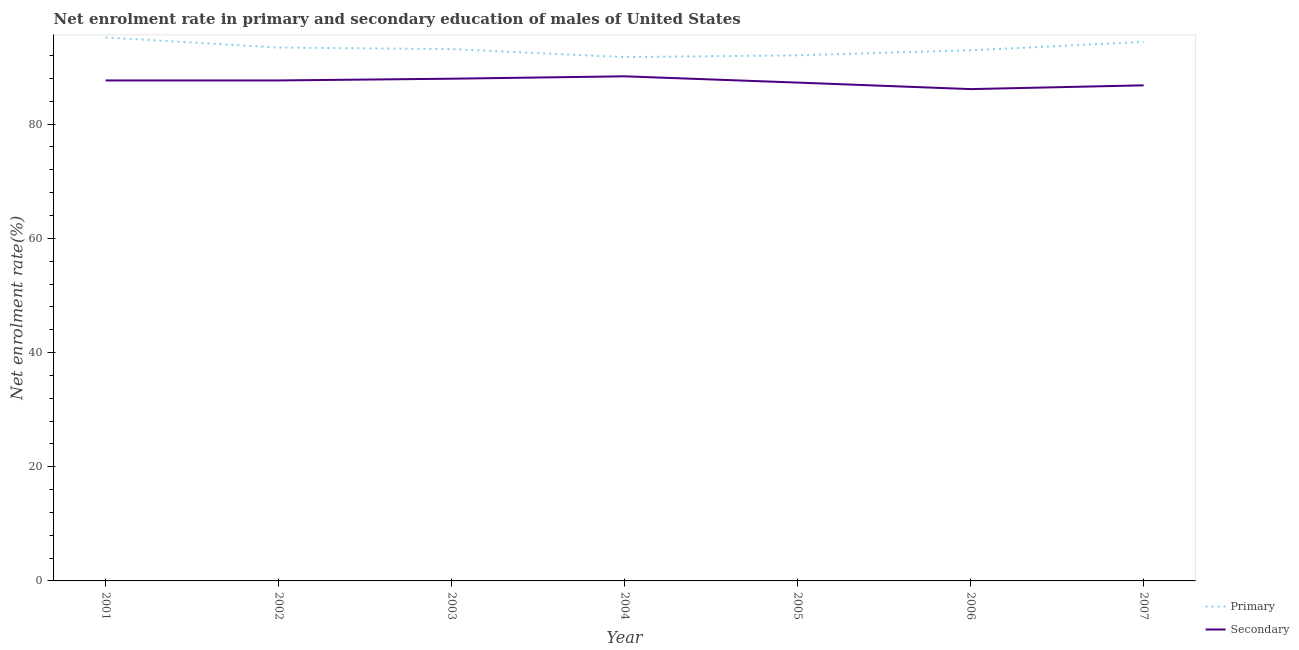Is the number of lines equal to the number of legend labels?
Ensure brevity in your answer.  Yes. What is the enrollment rate in secondary education in 2001?
Give a very brief answer. 87.65. Across all years, what is the maximum enrollment rate in primary education?
Provide a succinct answer. 95.18. Across all years, what is the minimum enrollment rate in secondary education?
Your answer should be compact. 86.13. What is the total enrollment rate in primary education in the graph?
Provide a short and direct response. 652.87. What is the difference between the enrollment rate in primary education in 2004 and that in 2006?
Make the answer very short. -1.2. What is the difference between the enrollment rate in secondary education in 2004 and the enrollment rate in primary education in 2006?
Your response must be concise. -4.56. What is the average enrollment rate in secondary education per year?
Provide a short and direct response. 87.41. In the year 2007, what is the difference between the enrollment rate in primary education and enrollment rate in secondary education?
Your answer should be compact. 7.61. In how many years, is the enrollment rate in primary education greater than 84 %?
Your response must be concise. 7. What is the ratio of the enrollment rate in primary education in 2004 to that in 2006?
Offer a terse response. 0.99. Is the enrollment rate in secondary education in 2001 less than that in 2002?
Your answer should be compact. Yes. What is the difference between the highest and the second highest enrollment rate in primary education?
Ensure brevity in your answer.  0.77. What is the difference between the highest and the lowest enrollment rate in secondary education?
Offer a very short reply. 2.24. Is the sum of the enrollment rate in secondary education in 2004 and 2006 greater than the maximum enrollment rate in primary education across all years?
Ensure brevity in your answer.  Yes. Is the enrollment rate in secondary education strictly greater than the enrollment rate in primary education over the years?
Ensure brevity in your answer.  No. What is the difference between two consecutive major ticks on the Y-axis?
Offer a very short reply. 20. Does the graph contain any zero values?
Provide a short and direct response. No. Does the graph contain grids?
Your answer should be compact. No. What is the title of the graph?
Give a very brief answer. Net enrolment rate in primary and secondary education of males of United States. What is the label or title of the Y-axis?
Provide a succinct answer. Net enrolment rate(%). What is the Net enrolment rate(%) in Primary in 2001?
Provide a short and direct response. 95.18. What is the Net enrolment rate(%) in Secondary in 2001?
Offer a very short reply. 87.65. What is the Net enrolment rate(%) in Primary in 2002?
Offer a terse response. 93.41. What is the Net enrolment rate(%) of Secondary in 2002?
Your answer should be very brief. 87.65. What is the Net enrolment rate(%) in Primary in 2003?
Provide a short and direct response. 93.14. What is the Net enrolment rate(%) of Secondary in 2003?
Ensure brevity in your answer.  87.96. What is the Net enrolment rate(%) in Primary in 2004?
Keep it short and to the point. 91.74. What is the Net enrolment rate(%) in Secondary in 2004?
Provide a succinct answer. 88.38. What is the Net enrolment rate(%) of Primary in 2005?
Your answer should be compact. 92.05. What is the Net enrolment rate(%) of Secondary in 2005?
Give a very brief answer. 87.27. What is the Net enrolment rate(%) of Primary in 2006?
Your response must be concise. 92.94. What is the Net enrolment rate(%) in Secondary in 2006?
Give a very brief answer. 86.13. What is the Net enrolment rate(%) of Primary in 2007?
Provide a succinct answer. 94.41. What is the Net enrolment rate(%) in Secondary in 2007?
Offer a very short reply. 86.8. Across all years, what is the maximum Net enrolment rate(%) in Primary?
Provide a short and direct response. 95.18. Across all years, what is the maximum Net enrolment rate(%) of Secondary?
Your response must be concise. 88.38. Across all years, what is the minimum Net enrolment rate(%) in Primary?
Your answer should be compact. 91.74. Across all years, what is the minimum Net enrolment rate(%) of Secondary?
Make the answer very short. 86.13. What is the total Net enrolment rate(%) of Primary in the graph?
Give a very brief answer. 652.87. What is the total Net enrolment rate(%) in Secondary in the graph?
Your answer should be compact. 611.84. What is the difference between the Net enrolment rate(%) of Primary in 2001 and that in 2002?
Provide a succinct answer. 1.77. What is the difference between the Net enrolment rate(%) of Secondary in 2001 and that in 2002?
Your response must be concise. -0. What is the difference between the Net enrolment rate(%) in Primary in 2001 and that in 2003?
Your answer should be very brief. 2.04. What is the difference between the Net enrolment rate(%) in Secondary in 2001 and that in 2003?
Your response must be concise. -0.3. What is the difference between the Net enrolment rate(%) in Primary in 2001 and that in 2004?
Ensure brevity in your answer.  3.44. What is the difference between the Net enrolment rate(%) in Secondary in 2001 and that in 2004?
Your answer should be compact. -0.72. What is the difference between the Net enrolment rate(%) of Primary in 2001 and that in 2005?
Keep it short and to the point. 3.13. What is the difference between the Net enrolment rate(%) in Secondary in 2001 and that in 2005?
Your answer should be compact. 0.38. What is the difference between the Net enrolment rate(%) in Primary in 2001 and that in 2006?
Provide a succinct answer. 2.24. What is the difference between the Net enrolment rate(%) of Secondary in 2001 and that in 2006?
Give a very brief answer. 1.52. What is the difference between the Net enrolment rate(%) in Primary in 2001 and that in 2007?
Provide a short and direct response. 0.77. What is the difference between the Net enrolment rate(%) in Secondary in 2001 and that in 2007?
Offer a terse response. 0.86. What is the difference between the Net enrolment rate(%) in Primary in 2002 and that in 2003?
Your answer should be compact. 0.28. What is the difference between the Net enrolment rate(%) in Secondary in 2002 and that in 2003?
Offer a very short reply. -0.3. What is the difference between the Net enrolment rate(%) in Primary in 2002 and that in 2004?
Your answer should be very brief. 1.67. What is the difference between the Net enrolment rate(%) of Secondary in 2002 and that in 2004?
Your response must be concise. -0.72. What is the difference between the Net enrolment rate(%) of Primary in 2002 and that in 2005?
Provide a short and direct response. 1.36. What is the difference between the Net enrolment rate(%) of Secondary in 2002 and that in 2005?
Give a very brief answer. 0.38. What is the difference between the Net enrolment rate(%) of Primary in 2002 and that in 2006?
Your answer should be very brief. 0.47. What is the difference between the Net enrolment rate(%) of Secondary in 2002 and that in 2006?
Offer a very short reply. 1.52. What is the difference between the Net enrolment rate(%) in Primary in 2002 and that in 2007?
Give a very brief answer. -0.99. What is the difference between the Net enrolment rate(%) in Secondary in 2002 and that in 2007?
Offer a very short reply. 0.86. What is the difference between the Net enrolment rate(%) of Primary in 2003 and that in 2004?
Offer a very short reply. 1.4. What is the difference between the Net enrolment rate(%) in Secondary in 2003 and that in 2004?
Ensure brevity in your answer.  -0.42. What is the difference between the Net enrolment rate(%) of Primary in 2003 and that in 2005?
Your response must be concise. 1.09. What is the difference between the Net enrolment rate(%) of Secondary in 2003 and that in 2005?
Offer a very short reply. 0.68. What is the difference between the Net enrolment rate(%) in Primary in 2003 and that in 2006?
Provide a short and direct response. 0.2. What is the difference between the Net enrolment rate(%) of Secondary in 2003 and that in 2006?
Offer a terse response. 1.82. What is the difference between the Net enrolment rate(%) of Primary in 2003 and that in 2007?
Your response must be concise. -1.27. What is the difference between the Net enrolment rate(%) of Secondary in 2003 and that in 2007?
Your answer should be very brief. 1.16. What is the difference between the Net enrolment rate(%) of Primary in 2004 and that in 2005?
Make the answer very short. -0.31. What is the difference between the Net enrolment rate(%) in Secondary in 2004 and that in 2005?
Provide a succinct answer. 1.1. What is the difference between the Net enrolment rate(%) of Primary in 2004 and that in 2006?
Provide a short and direct response. -1.2. What is the difference between the Net enrolment rate(%) of Secondary in 2004 and that in 2006?
Provide a short and direct response. 2.24. What is the difference between the Net enrolment rate(%) of Primary in 2004 and that in 2007?
Provide a succinct answer. -2.67. What is the difference between the Net enrolment rate(%) of Secondary in 2004 and that in 2007?
Offer a terse response. 1.58. What is the difference between the Net enrolment rate(%) of Primary in 2005 and that in 2006?
Give a very brief answer. -0.89. What is the difference between the Net enrolment rate(%) of Secondary in 2005 and that in 2006?
Make the answer very short. 1.14. What is the difference between the Net enrolment rate(%) in Primary in 2005 and that in 2007?
Ensure brevity in your answer.  -2.36. What is the difference between the Net enrolment rate(%) of Secondary in 2005 and that in 2007?
Your answer should be compact. 0.48. What is the difference between the Net enrolment rate(%) in Primary in 2006 and that in 2007?
Make the answer very short. -1.47. What is the difference between the Net enrolment rate(%) of Secondary in 2006 and that in 2007?
Keep it short and to the point. -0.66. What is the difference between the Net enrolment rate(%) of Primary in 2001 and the Net enrolment rate(%) of Secondary in 2002?
Give a very brief answer. 7.53. What is the difference between the Net enrolment rate(%) of Primary in 2001 and the Net enrolment rate(%) of Secondary in 2003?
Offer a very short reply. 7.22. What is the difference between the Net enrolment rate(%) of Primary in 2001 and the Net enrolment rate(%) of Secondary in 2004?
Offer a terse response. 6.8. What is the difference between the Net enrolment rate(%) in Primary in 2001 and the Net enrolment rate(%) in Secondary in 2005?
Your answer should be very brief. 7.91. What is the difference between the Net enrolment rate(%) in Primary in 2001 and the Net enrolment rate(%) in Secondary in 2006?
Ensure brevity in your answer.  9.05. What is the difference between the Net enrolment rate(%) in Primary in 2001 and the Net enrolment rate(%) in Secondary in 2007?
Your answer should be very brief. 8.38. What is the difference between the Net enrolment rate(%) of Primary in 2002 and the Net enrolment rate(%) of Secondary in 2003?
Ensure brevity in your answer.  5.46. What is the difference between the Net enrolment rate(%) in Primary in 2002 and the Net enrolment rate(%) in Secondary in 2004?
Offer a terse response. 5.04. What is the difference between the Net enrolment rate(%) in Primary in 2002 and the Net enrolment rate(%) in Secondary in 2005?
Keep it short and to the point. 6.14. What is the difference between the Net enrolment rate(%) in Primary in 2002 and the Net enrolment rate(%) in Secondary in 2006?
Your response must be concise. 7.28. What is the difference between the Net enrolment rate(%) in Primary in 2002 and the Net enrolment rate(%) in Secondary in 2007?
Provide a succinct answer. 6.62. What is the difference between the Net enrolment rate(%) of Primary in 2003 and the Net enrolment rate(%) of Secondary in 2004?
Keep it short and to the point. 4.76. What is the difference between the Net enrolment rate(%) of Primary in 2003 and the Net enrolment rate(%) of Secondary in 2005?
Keep it short and to the point. 5.86. What is the difference between the Net enrolment rate(%) of Primary in 2003 and the Net enrolment rate(%) of Secondary in 2006?
Ensure brevity in your answer.  7. What is the difference between the Net enrolment rate(%) of Primary in 2003 and the Net enrolment rate(%) of Secondary in 2007?
Provide a short and direct response. 6.34. What is the difference between the Net enrolment rate(%) in Primary in 2004 and the Net enrolment rate(%) in Secondary in 2005?
Provide a short and direct response. 4.47. What is the difference between the Net enrolment rate(%) in Primary in 2004 and the Net enrolment rate(%) in Secondary in 2006?
Keep it short and to the point. 5.61. What is the difference between the Net enrolment rate(%) in Primary in 2004 and the Net enrolment rate(%) in Secondary in 2007?
Ensure brevity in your answer.  4.94. What is the difference between the Net enrolment rate(%) in Primary in 2005 and the Net enrolment rate(%) in Secondary in 2006?
Give a very brief answer. 5.91. What is the difference between the Net enrolment rate(%) of Primary in 2005 and the Net enrolment rate(%) of Secondary in 2007?
Your response must be concise. 5.25. What is the difference between the Net enrolment rate(%) in Primary in 2006 and the Net enrolment rate(%) in Secondary in 2007?
Provide a short and direct response. 6.14. What is the average Net enrolment rate(%) of Primary per year?
Keep it short and to the point. 93.27. What is the average Net enrolment rate(%) of Secondary per year?
Provide a succinct answer. 87.41. In the year 2001, what is the difference between the Net enrolment rate(%) of Primary and Net enrolment rate(%) of Secondary?
Your response must be concise. 7.53. In the year 2002, what is the difference between the Net enrolment rate(%) in Primary and Net enrolment rate(%) in Secondary?
Ensure brevity in your answer.  5.76. In the year 2003, what is the difference between the Net enrolment rate(%) of Primary and Net enrolment rate(%) of Secondary?
Provide a succinct answer. 5.18. In the year 2004, what is the difference between the Net enrolment rate(%) of Primary and Net enrolment rate(%) of Secondary?
Your response must be concise. 3.37. In the year 2005, what is the difference between the Net enrolment rate(%) of Primary and Net enrolment rate(%) of Secondary?
Make the answer very short. 4.77. In the year 2006, what is the difference between the Net enrolment rate(%) of Primary and Net enrolment rate(%) of Secondary?
Ensure brevity in your answer.  6.81. In the year 2007, what is the difference between the Net enrolment rate(%) in Primary and Net enrolment rate(%) in Secondary?
Give a very brief answer. 7.61. What is the ratio of the Net enrolment rate(%) of Primary in 2001 to that in 2002?
Keep it short and to the point. 1.02. What is the ratio of the Net enrolment rate(%) of Secondary in 2001 to that in 2002?
Make the answer very short. 1. What is the ratio of the Net enrolment rate(%) in Primary in 2001 to that in 2003?
Provide a succinct answer. 1.02. What is the ratio of the Net enrolment rate(%) of Secondary in 2001 to that in 2003?
Ensure brevity in your answer.  1. What is the ratio of the Net enrolment rate(%) in Primary in 2001 to that in 2004?
Offer a very short reply. 1.04. What is the ratio of the Net enrolment rate(%) of Primary in 2001 to that in 2005?
Your answer should be compact. 1.03. What is the ratio of the Net enrolment rate(%) in Secondary in 2001 to that in 2005?
Ensure brevity in your answer.  1. What is the ratio of the Net enrolment rate(%) of Primary in 2001 to that in 2006?
Your answer should be very brief. 1.02. What is the ratio of the Net enrolment rate(%) in Secondary in 2001 to that in 2006?
Keep it short and to the point. 1.02. What is the ratio of the Net enrolment rate(%) in Primary in 2001 to that in 2007?
Provide a succinct answer. 1.01. What is the ratio of the Net enrolment rate(%) in Secondary in 2001 to that in 2007?
Offer a terse response. 1.01. What is the ratio of the Net enrolment rate(%) of Secondary in 2002 to that in 2003?
Provide a succinct answer. 1. What is the ratio of the Net enrolment rate(%) in Primary in 2002 to that in 2004?
Provide a short and direct response. 1.02. What is the ratio of the Net enrolment rate(%) of Primary in 2002 to that in 2005?
Make the answer very short. 1.01. What is the ratio of the Net enrolment rate(%) in Primary in 2002 to that in 2006?
Ensure brevity in your answer.  1.01. What is the ratio of the Net enrolment rate(%) in Secondary in 2002 to that in 2006?
Offer a terse response. 1.02. What is the ratio of the Net enrolment rate(%) in Secondary in 2002 to that in 2007?
Make the answer very short. 1.01. What is the ratio of the Net enrolment rate(%) in Primary in 2003 to that in 2004?
Ensure brevity in your answer.  1.02. What is the ratio of the Net enrolment rate(%) of Secondary in 2003 to that in 2004?
Give a very brief answer. 1. What is the ratio of the Net enrolment rate(%) in Primary in 2003 to that in 2005?
Give a very brief answer. 1.01. What is the ratio of the Net enrolment rate(%) in Secondary in 2003 to that in 2005?
Offer a very short reply. 1.01. What is the ratio of the Net enrolment rate(%) of Secondary in 2003 to that in 2006?
Provide a succinct answer. 1.02. What is the ratio of the Net enrolment rate(%) in Primary in 2003 to that in 2007?
Your response must be concise. 0.99. What is the ratio of the Net enrolment rate(%) of Secondary in 2003 to that in 2007?
Your answer should be very brief. 1.01. What is the ratio of the Net enrolment rate(%) in Secondary in 2004 to that in 2005?
Give a very brief answer. 1.01. What is the ratio of the Net enrolment rate(%) in Primary in 2004 to that in 2006?
Provide a succinct answer. 0.99. What is the ratio of the Net enrolment rate(%) of Secondary in 2004 to that in 2006?
Provide a succinct answer. 1.03. What is the ratio of the Net enrolment rate(%) in Primary in 2004 to that in 2007?
Your response must be concise. 0.97. What is the ratio of the Net enrolment rate(%) in Secondary in 2004 to that in 2007?
Provide a succinct answer. 1.02. What is the ratio of the Net enrolment rate(%) in Primary in 2005 to that in 2006?
Make the answer very short. 0.99. What is the ratio of the Net enrolment rate(%) of Secondary in 2005 to that in 2006?
Provide a succinct answer. 1.01. What is the ratio of the Net enrolment rate(%) of Primary in 2006 to that in 2007?
Your answer should be very brief. 0.98. What is the ratio of the Net enrolment rate(%) of Secondary in 2006 to that in 2007?
Provide a succinct answer. 0.99. What is the difference between the highest and the second highest Net enrolment rate(%) in Primary?
Ensure brevity in your answer.  0.77. What is the difference between the highest and the second highest Net enrolment rate(%) of Secondary?
Your answer should be compact. 0.42. What is the difference between the highest and the lowest Net enrolment rate(%) of Primary?
Keep it short and to the point. 3.44. What is the difference between the highest and the lowest Net enrolment rate(%) in Secondary?
Your answer should be compact. 2.24. 